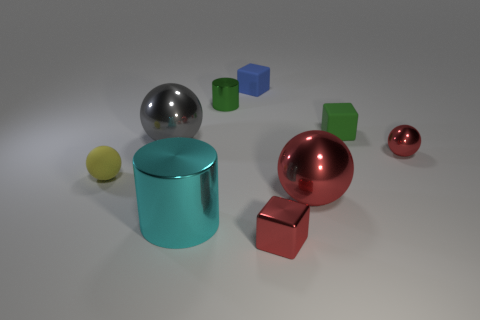Add 1 yellow rubber things. How many objects exist? 10 Subtract all gray spheres. How many spheres are left? 3 Subtract all yellow spheres. How many spheres are left? 3 Subtract 1 cyan cylinders. How many objects are left? 8 Subtract all balls. How many objects are left? 5 Subtract 1 cylinders. How many cylinders are left? 1 Subtract all brown cubes. Subtract all red balls. How many cubes are left? 3 Subtract all cyan blocks. How many brown balls are left? 0 Subtract all shiny cubes. Subtract all big spheres. How many objects are left? 6 Add 6 yellow rubber balls. How many yellow rubber balls are left? 7 